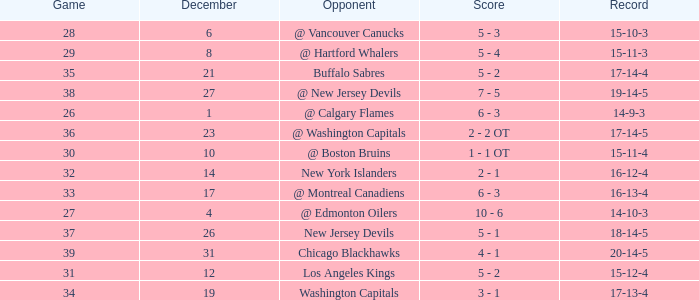Record of 15-12-4, and a Game larger than 31 involves what highest December? None. 